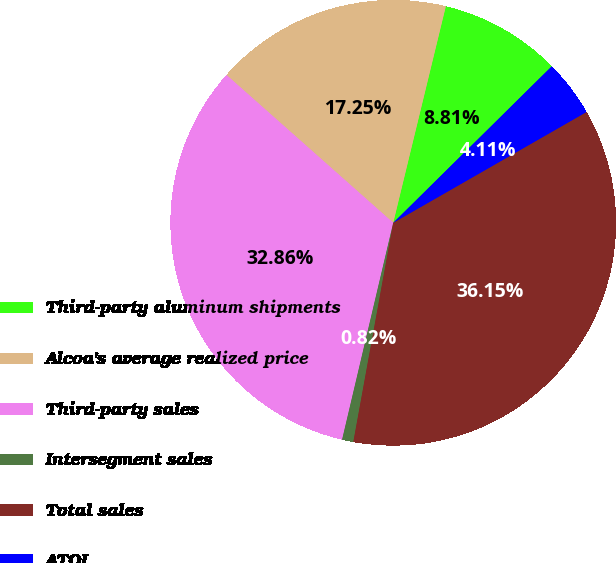Convert chart to OTSL. <chart><loc_0><loc_0><loc_500><loc_500><pie_chart><fcel>Third-party aluminum shipments<fcel>Alcoa's average realized price<fcel>Third-party sales<fcel>Intersegment sales<fcel>Total sales<fcel>ATOI<nl><fcel>8.81%<fcel>17.25%<fcel>32.86%<fcel>0.82%<fcel>36.15%<fcel>4.11%<nl></chart> 